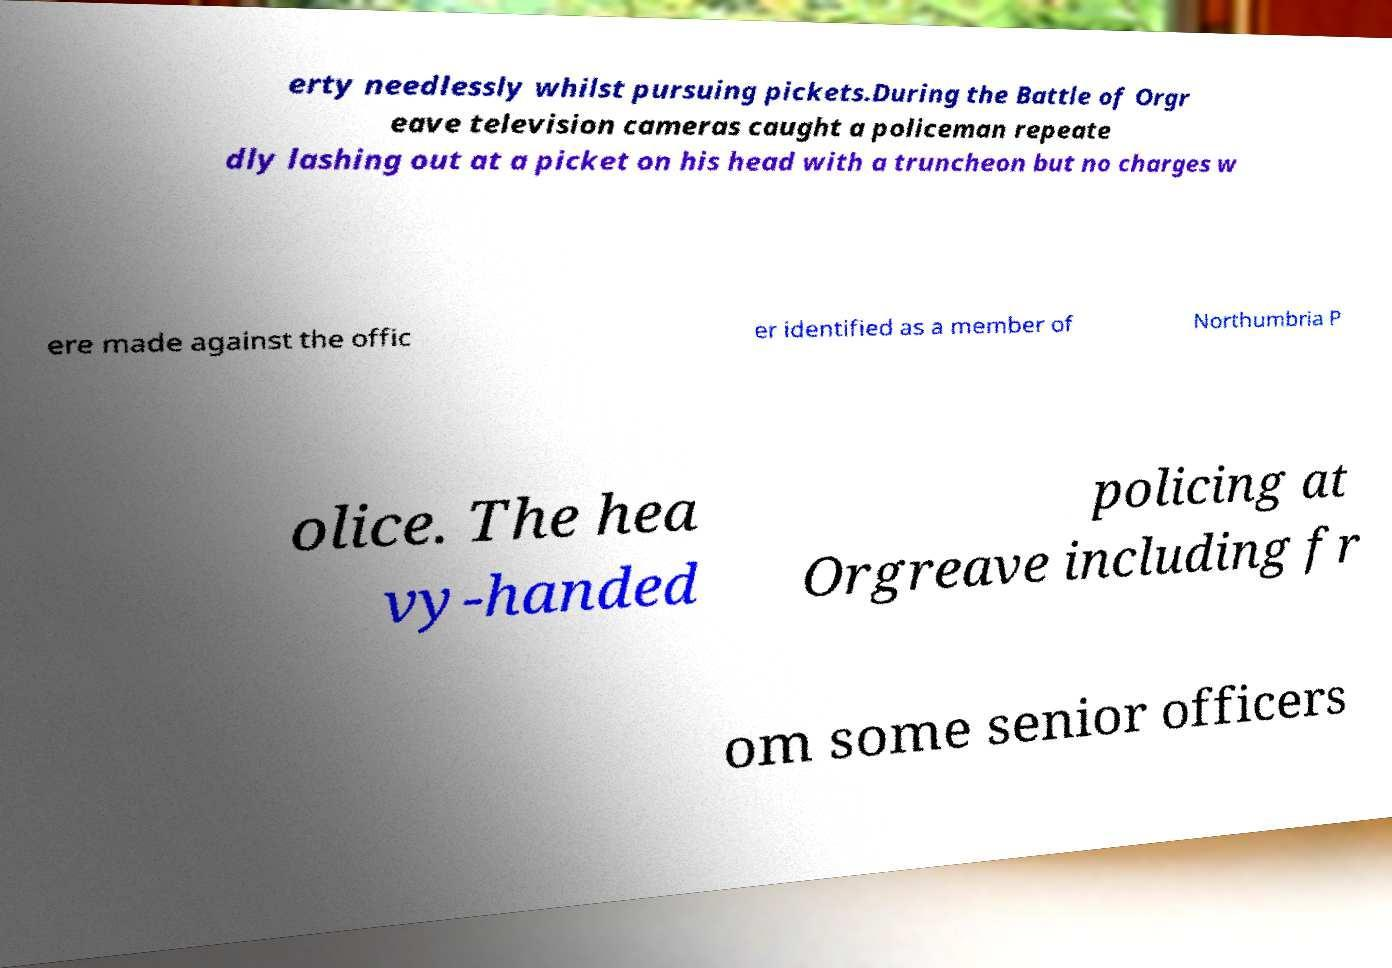Could you extract and type out the text from this image? erty needlessly whilst pursuing pickets.During the Battle of Orgr eave television cameras caught a policeman repeate dly lashing out at a picket on his head with a truncheon but no charges w ere made against the offic er identified as a member of Northumbria P olice. The hea vy-handed policing at Orgreave including fr om some senior officers 